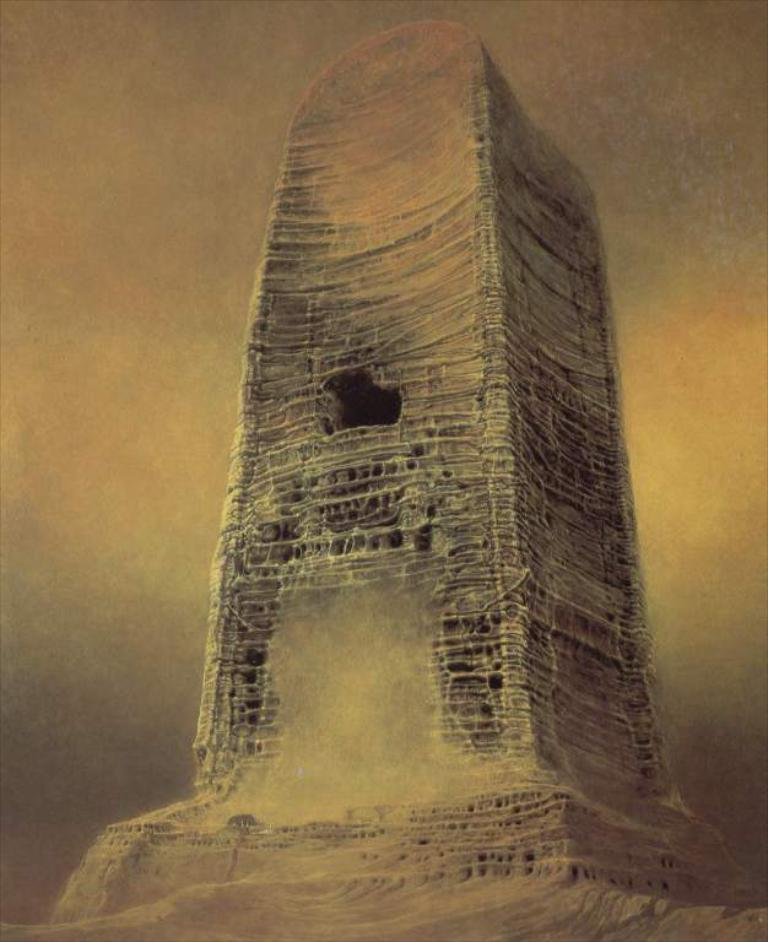What is the main subject of the image? The main subject of the image is a painting. Can you describe the colors used in the painting? The painting has yellow, orange, black, and grey colors. What is the most prominent feature of the painting? The painting features a huge object. What colors are used for the huge object in the painting? The huge object has black, orange, and cream colors. What type of drain is visible in the painting? There is no drain present in the painting; it features of the painting include a huge object with black, orange, and cream colors. 